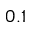Convert formula to latex. <formula><loc_0><loc_0><loc_500><loc_500>0 . 1</formula> 